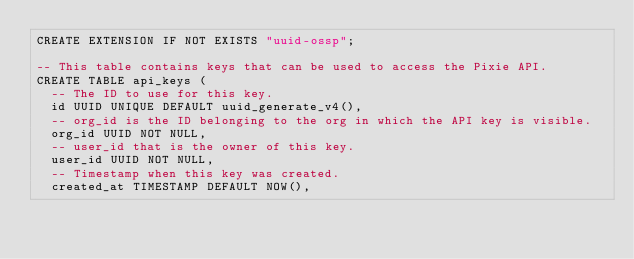Convert code to text. <code><loc_0><loc_0><loc_500><loc_500><_SQL_>CREATE EXTENSION IF NOT EXISTS "uuid-ossp";

-- This table contains keys that can be used to access the Pixie API.
CREATE TABLE api_keys (
  -- The ID to use for this key.
  id UUID UNIQUE DEFAULT uuid_generate_v4(),
  -- org_id is the ID belonging to the org in which the API key is visible.
  org_id UUID NOT NULL,
  -- user_id that is the owner of this key.
  user_id UUID NOT NULL,
  -- Timestamp when this key was created.
  created_at TIMESTAMP DEFAULT NOW(),</code> 